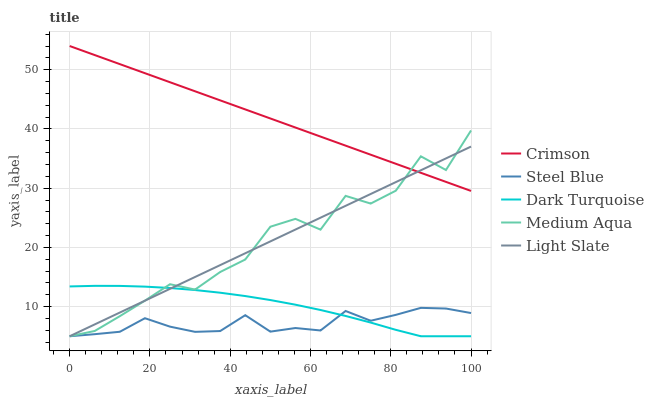Does Steel Blue have the minimum area under the curve?
Answer yes or no. Yes. Does Crimson have the maximum area under the curve?
Answer yes or no. Yes. Does Dark Turquoise have the minimum area under the curve?
Answer yes or no. No. Does Dark Turquoise have the maximum area under the curve?
Answer yes or no. No. Is Crimson the smoothest?
Answer yes or no. Yes. Is Medium Aqua the roughest?
Answer yes or no. Yes. Is Dark Turquoise the smoothest?
Answer yes or no. No. Is Dark Turquoise the roughest?
Answer yes or no. No. Does Dark Turquoise have the lowest value?
Answer yes or no. Yes. Does Crimson have the highest value?
Answer yes or no. Yes. Does Dark Turquoise have the highest value?
Answer yes or no. No. Is Steel Blue less than Crimson?
Answer yes or no. Yes. Is Crimson greater than Dark Turquoise?
Answer yes or no. Yes. Does Light Slate intersect Medium Aqua?
Answer yes or no. Yes. Is Light Slate less than Medium Aqua?
Answer yes or no. No. Is Light Slate greater than Medium Aqua?
Answer yes or no. No. Does Steel Blue intersect Crimson?
Answer yes or no. No. 